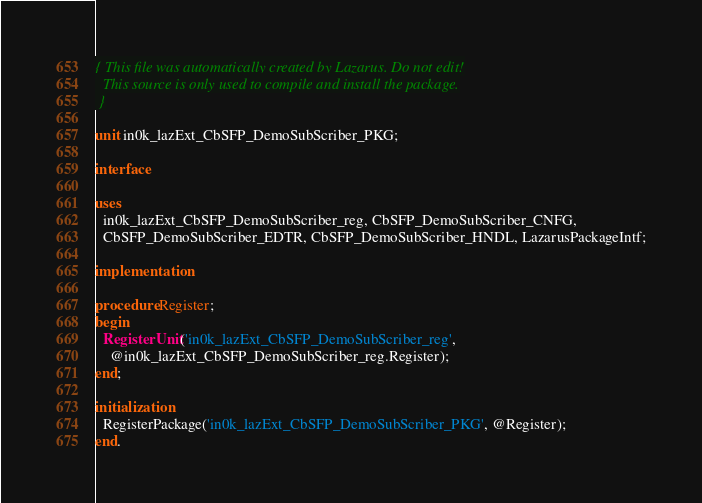<code> <loc_0><loc_0><loc_500><loc_500><_Pascal_>{ This file was automatically created by Lazarus. Do not edit!
  This source is only used to compile and install the package.
 }

unit in0k_lazExt_CbSFP_DemoSubScriber_PKG;

interface

uses
  in0k_lazExt_CbSFP_DemoSubScriber_reg, CbSFP_DemoSubScriber_CNFG, 
  CbSFP_DemoSubScriber_EDTR, CbSFP_DemoSubScriber_HNDL, LazarusPackageIntf;

implementation

procedure Register;
begin
  RegisterUnit('in0k_lazExt_CbSFP_DemoSubScriber_reg', 
    @in0k_lazExt_CbSFP_DemoSubScriber_reg.Register);
end;

initialization
  RegisterPackage('in0k_lazExt_CbSFP_DemoSubScriber_PKG', @Register);
end.
</code> 